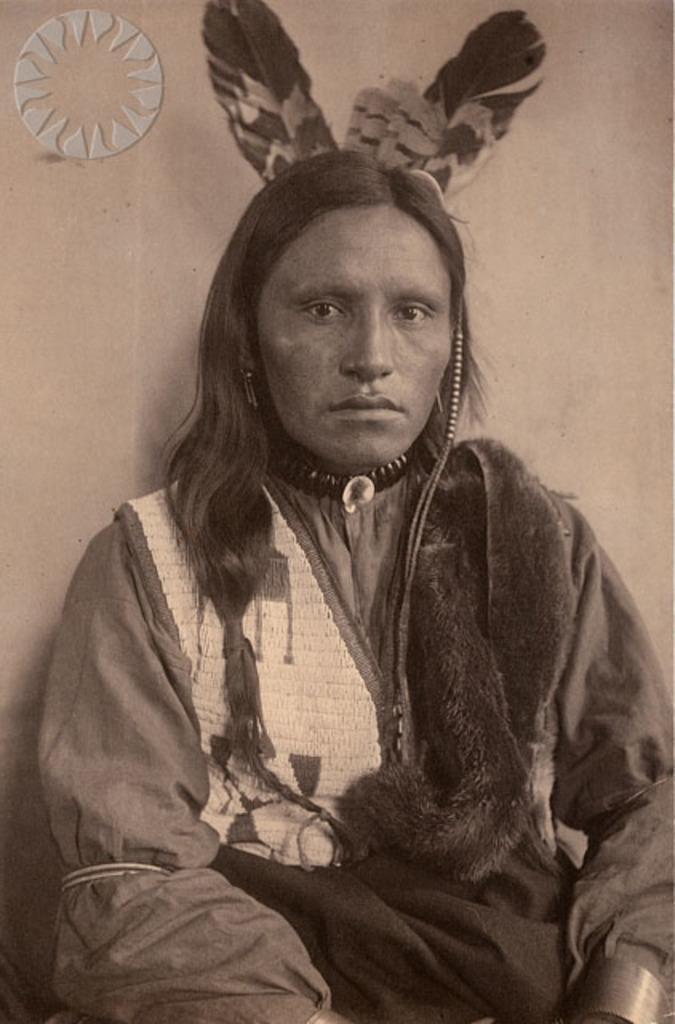Can you describe this image briefly? In this image there is a person in a fancy dress is sitting, and there are feathers, wall and a watermark on the image. 